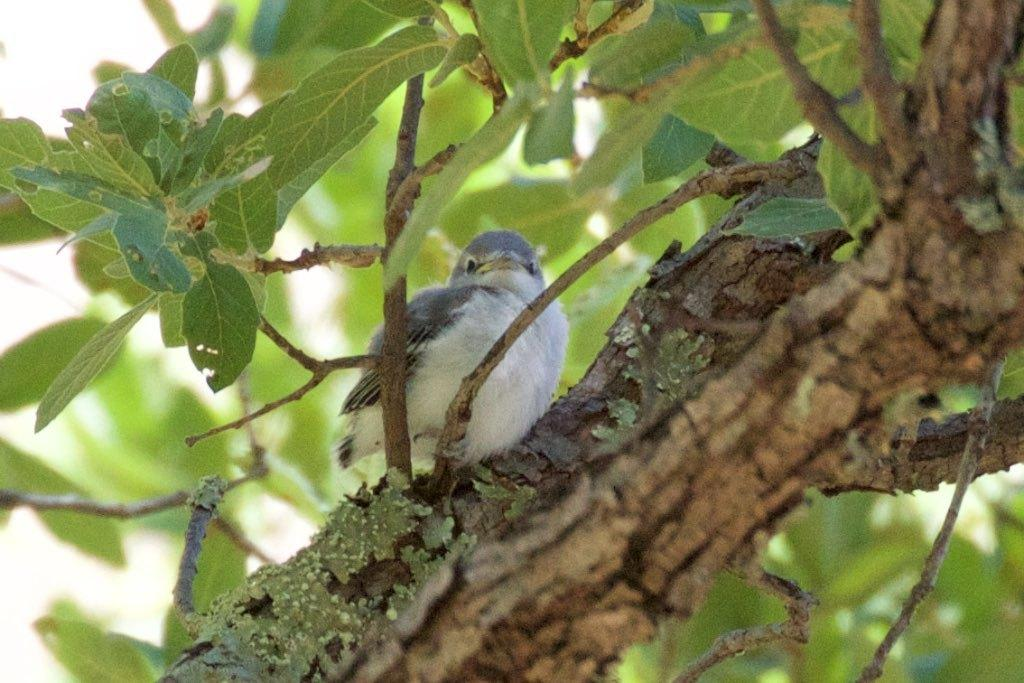What is the main object in the image? There is a tree trunk in the image. What is on the tree trunk? A bird is standing on the tree trunk. What else can be seen in the image besides the tree trunk and bird? There are leaves in the image. What type of yam is being used to make a statement in the image? There is no yam present in the image, and no statements are being made. 